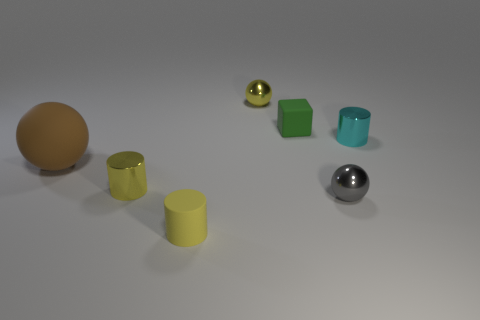Subtract all tiny metal balls. How many balls are left? 1 Subtract all gray balls. How many balls are left? 2 Subtract all cylinders. How many objects are left? 4 Add 3 large red rubber blocks. How many objects exist? 10 Subtract all yellow spheres. How many cyan cylinders are left? 1 Subtract all small brown spheres. Subtract all brown matte things. How many objects are left? 6 Add 3 small objects. How many small objects are left? 9 Add 6 brown matte things. How many brown matte things exist? 7 Subtract 0 brown cylinders. How many objects are left? 7 Subtract 1 balls. How many balls are left? 2 